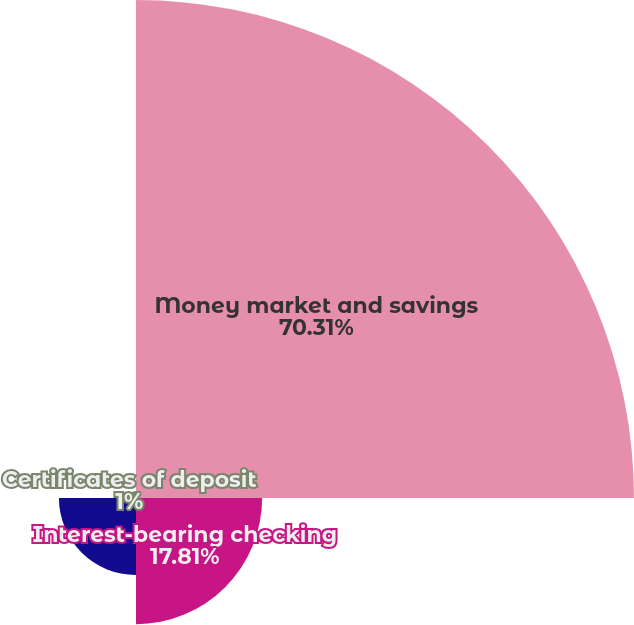<chart> <loc_0><loc_0><loc_500><loc_500><pie_chart><fcel>Money market and savings<fcel>Interest-bearing checking<fcel>IRAs<fcel>Certificates of deposit<nl><fcel>70.31%<fcel>17.81%<fcel>10.88%<fcel>1.0%<nl></chart> 